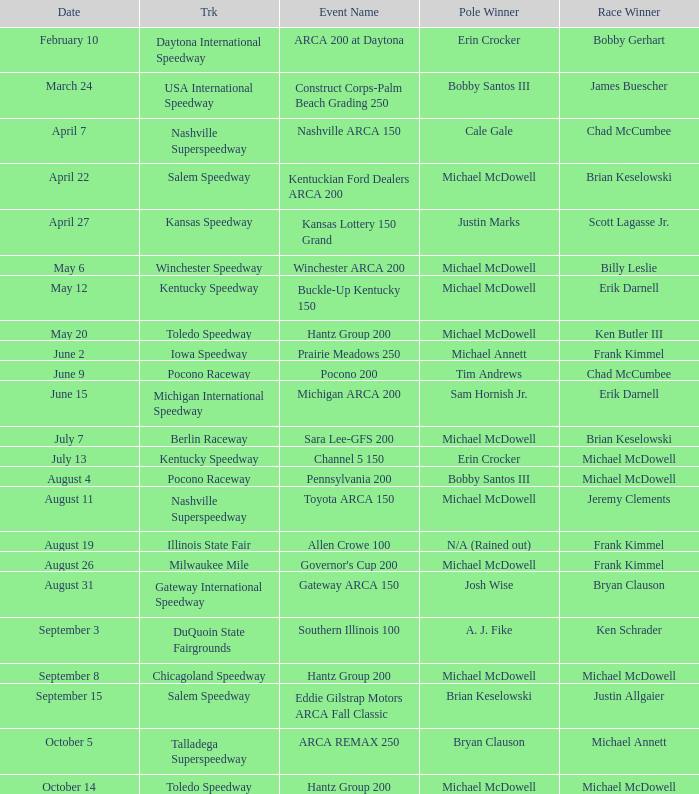Tell me the track for scott lagasse jr. Kansas Speedway. 